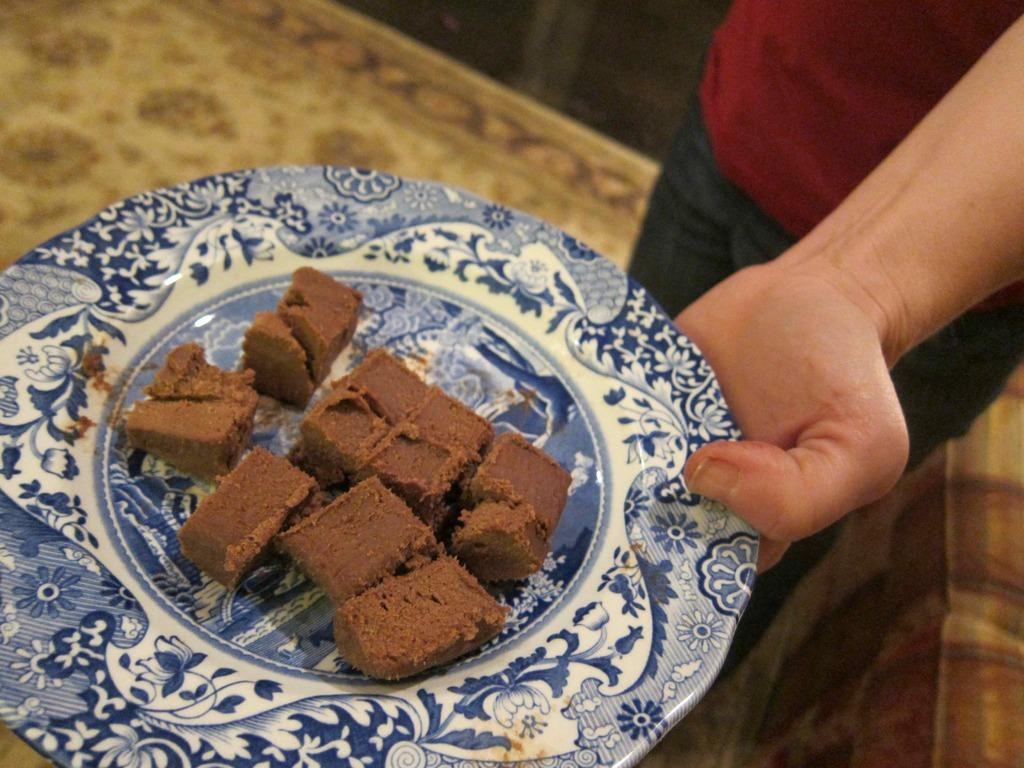Who is present in the image? There is a person in the image. What is the person wearing? The person is wearing a red t-shirt. What is the person holding in the image? The person is holding a plate containing food. Where is the person standing? The person is standing on the floor. What type of door can be seen in the image? There is no door present in the image. 